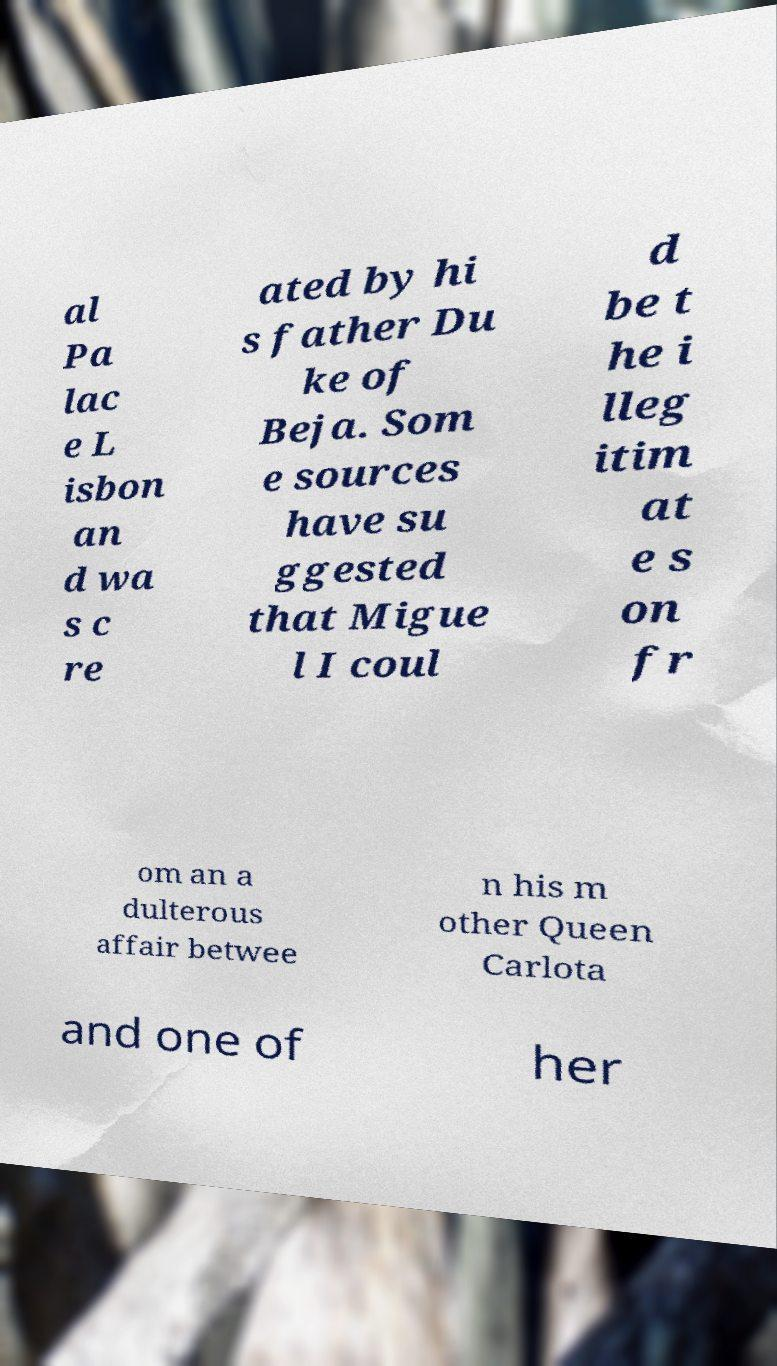Could you extract and type out the text from this image? al Pa lac e L isbon an d wa s c re ated by hi s father Du ke of Beja. Som e sources have su ggested that Migue l I coul d be t he i lleg itim at e s on fr om an a dulterous affair betwee n his m other Queen Carlota and one of her 